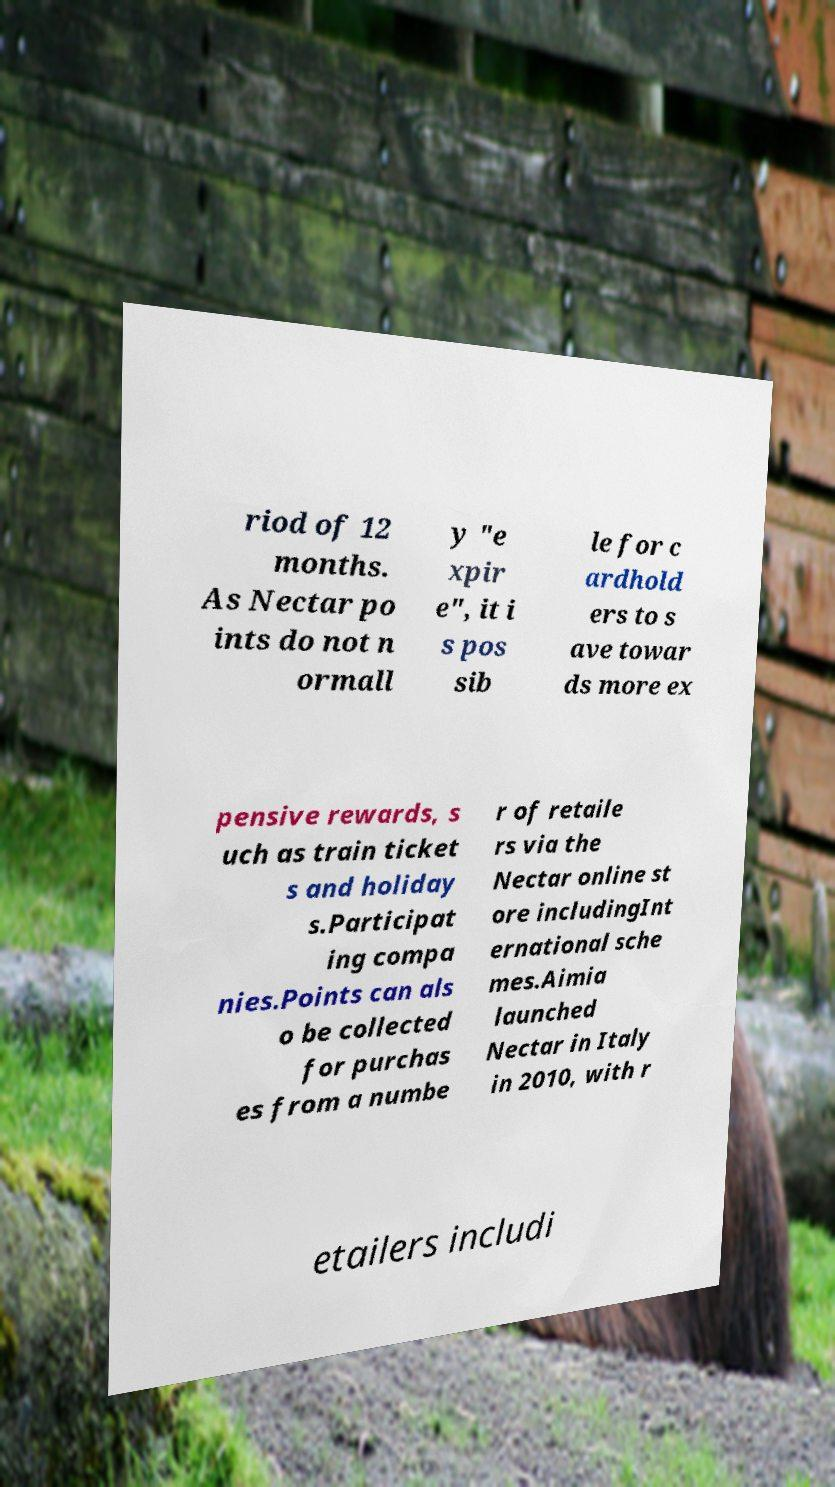What messages or text are displayed in this image? I need them in a readable, typed format. riod of 12 months. As Nectar po ints do not n ormall y "e xpir e", it i s pos sib le for c ardhold ers to s ave towar ds more ex pensive rewards, s uch as train ticket s and holiday s.Participat ing compa nies.Points can als o be collected for purchas es from a numbe r of retaile rs via the Nectar online st ore includingInt ernational sche mes.Aimia launched Nectar in Italy in 2010, with r etailers includi 